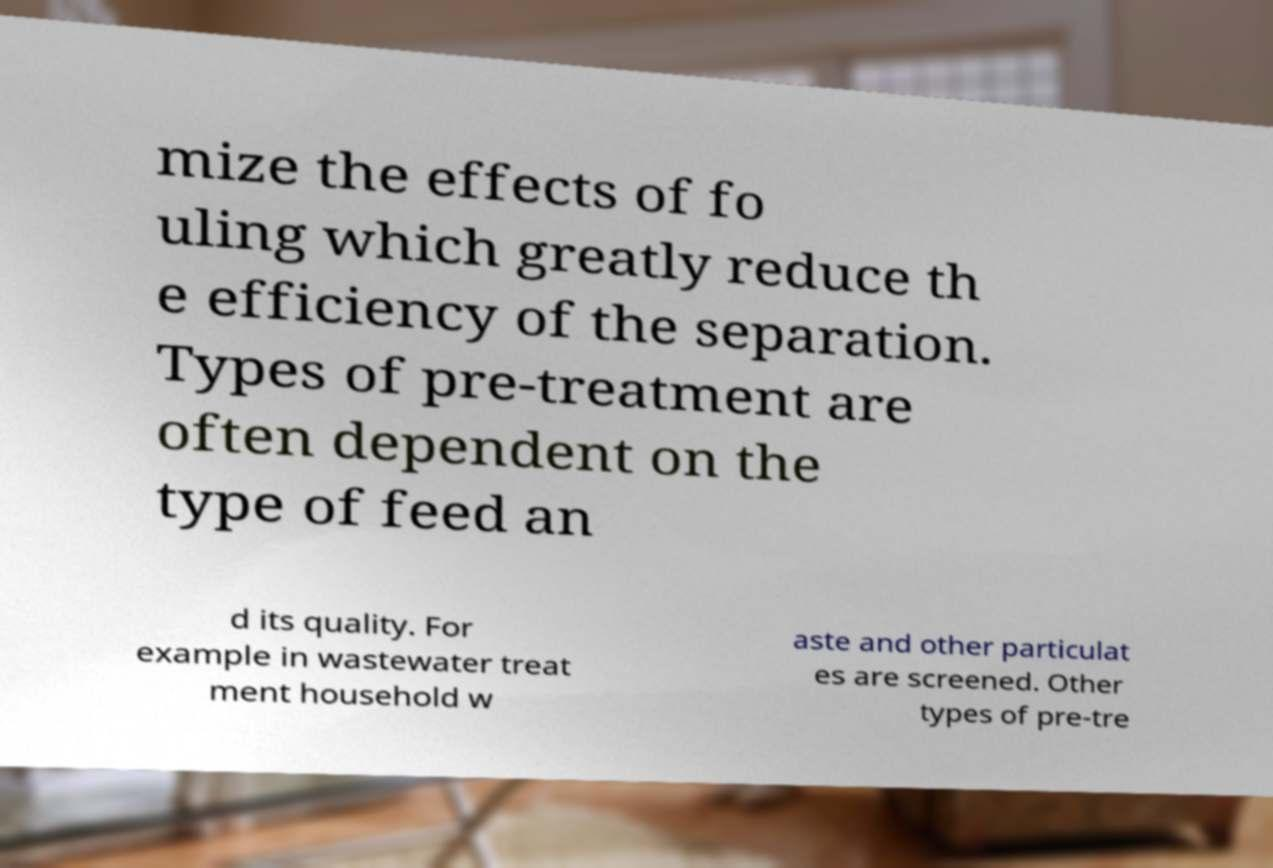Could you assist in decoding the text presented in this image and type it out clearly? mize the effects of fo uling which greatly reduce th e efficiency of the separation. Types of pre-treatment are often dependent on the type of feed an d its quality. For example in wastewater treat ment household w aste and other particulat es are screened. Other types of pre-tre 